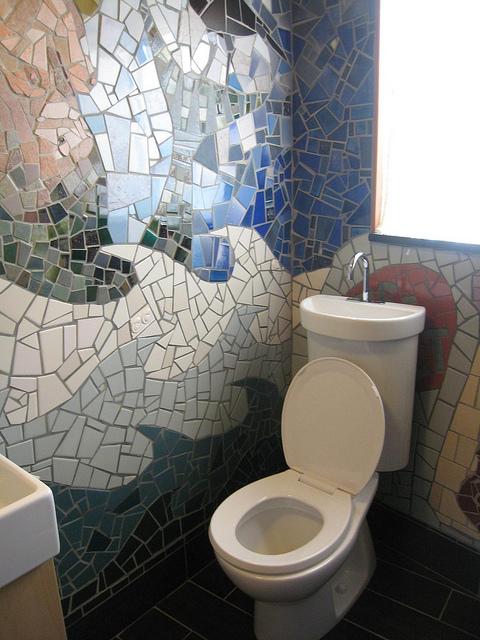Is the mosaic religious?
Give a very brief answer. No. Did the toilet put up the mosaic?
Write a very short answer. No. Is the wall decorated with a mosaic?
Keep it brief. Yes. 